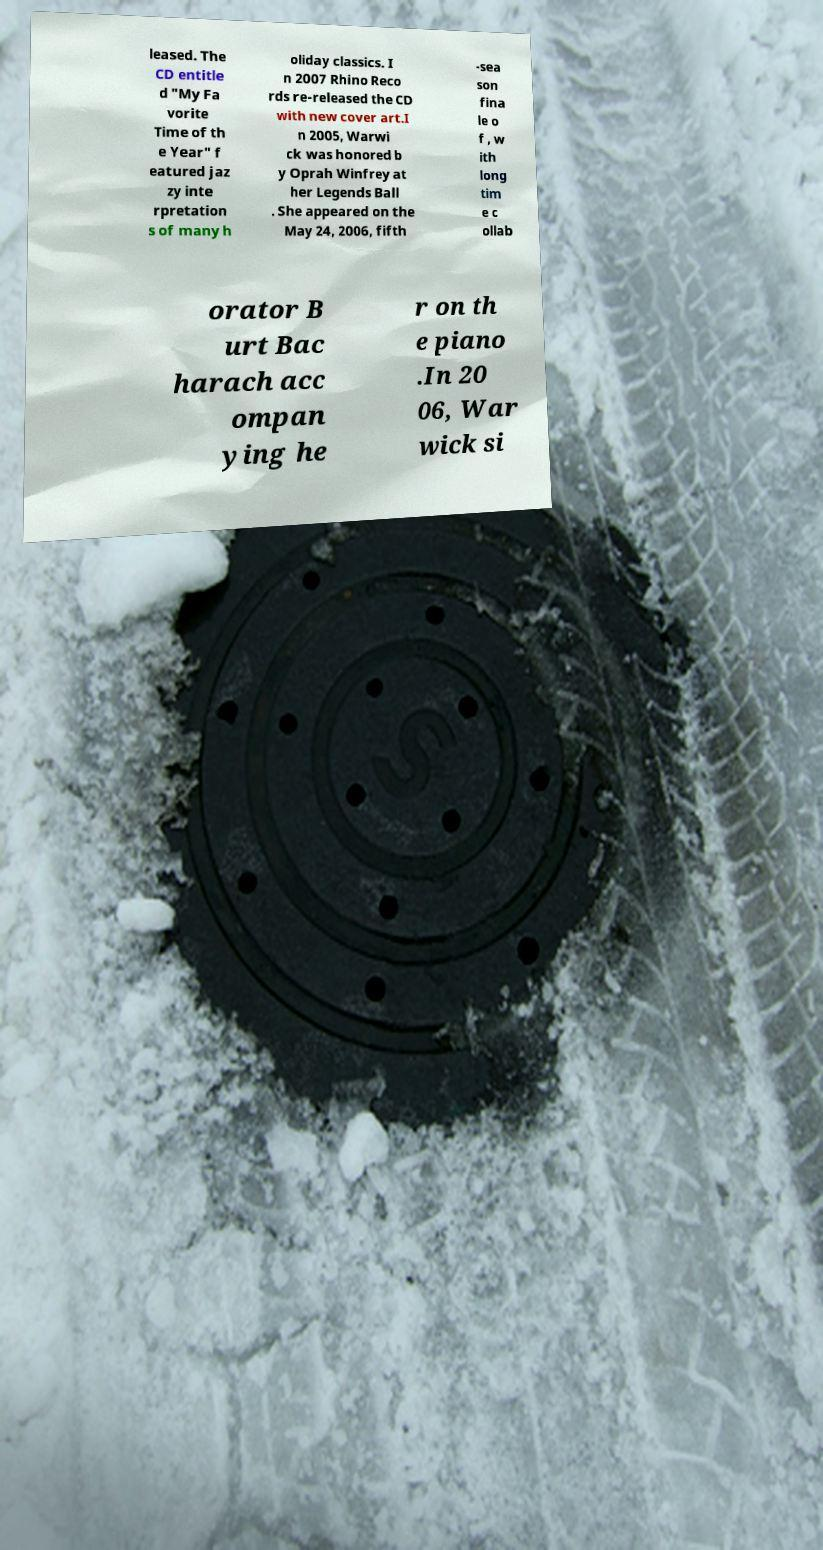Could you assist in decoding the text presented in this image and type it out clearly? leased. The CD entitle d "My Fa vorite Time of th e Year" f eatured jaz zy inte rpretation s of many h oliday classics. I n 2007 Rhino Reco rds re-released the CD with new cover art.I n 2005, Warwi ck was honored b y Oprah Winfrey at her Legends Ball . She appeared on the May 24, 2006, fifth -sea son fina le o f , w ith long tim e c ollab orator B urt Bac harach acc ompan ying he r on th e piano .In 20 06, War wick si 